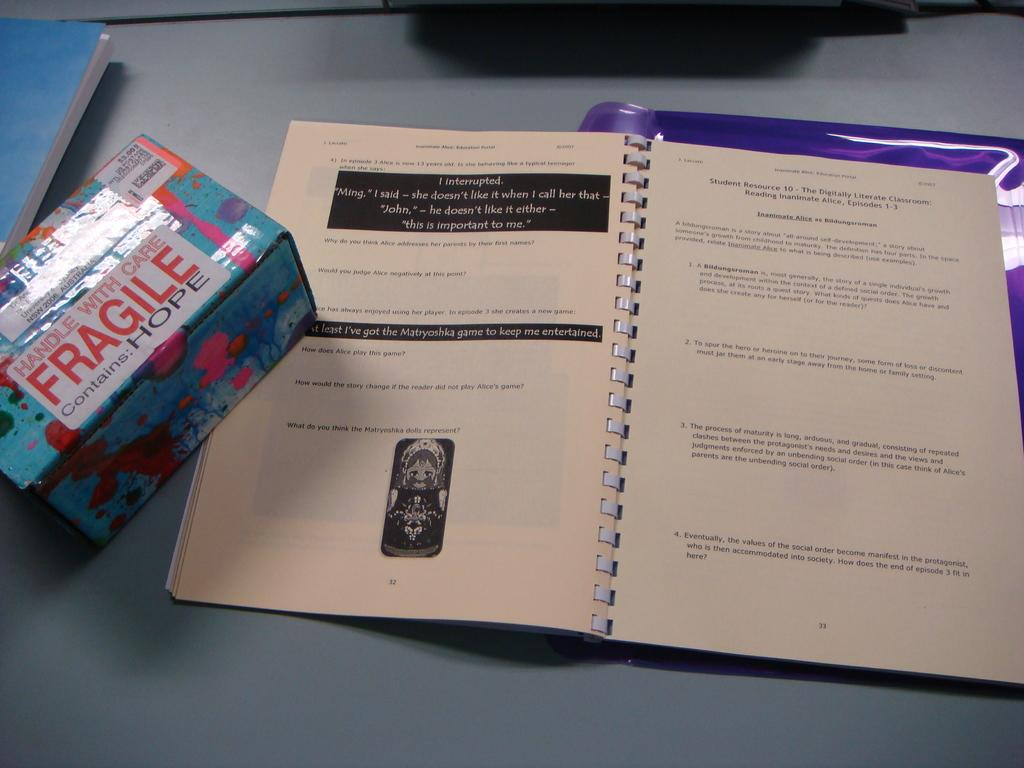<image>
Create a compact narrative representing the image presented. A box on the desk says it is fragile and it contains hope. 